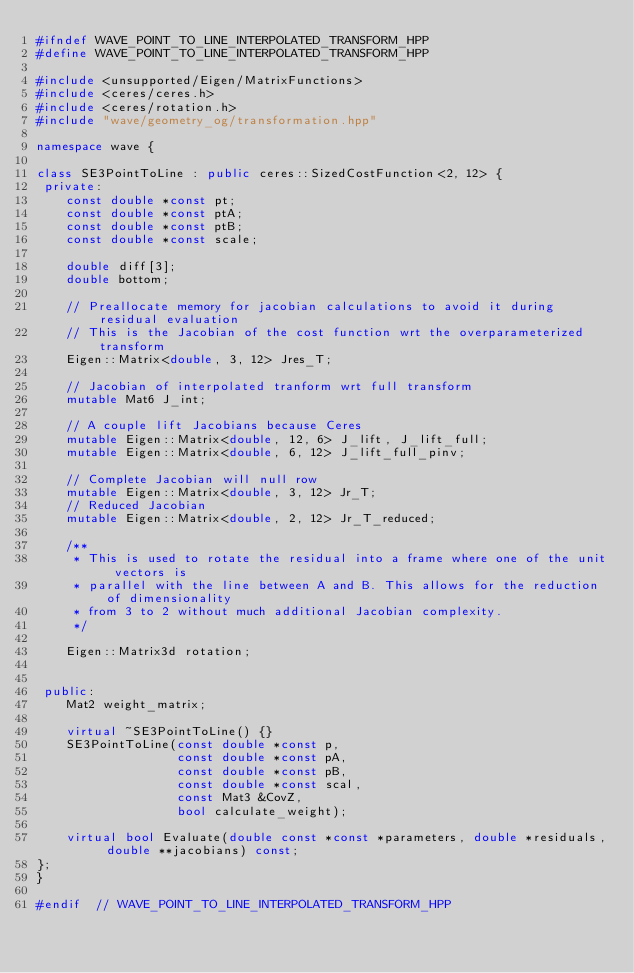<code> <loc_0><loc_0><loc_500><loc_500><_C++_>#ifndef WAVE_POINT_TO_LINE_INTERPOLATED_TRANSFORM_HPP
#define WAVE_POINT_TO_LINE_INTERPOLATED_TRANSFORM_HPP

#include <unsupported/Eigen/MatrixFunctions>
#include <ceres/ceres.h>
#include <ceres/rotation.h>
#include "wave/geometry_og/transformation.hpp"

namespace wave {

class SE3PointToLine : public ceres::SizedCostFunction<2, 12> {
 private:
    const double *const pt;
    const double *const ptA;
    const double *const ptB;
    const double *const scale;

    double diff[3];
    double bottom;

    // Preallocate memory for jacobian calculations to avoid it during residual evaluation
    // This is the Jacobian of the cost function wrt the overparameterized transform
    Eigen::Matrix<double, 3, 12> Jres_T;

    // Jacobian of interpolated tranform wrt full transform
    mutable Mat6 J_int;

    // A couple lift Jacobians because Ceres
    mutable Eigen::Matrix<double, 12, 6> J_lift, J_lift_full;
    mutable Eigen::Matrix<double, 6, 12> J_lift_full_pinv;

    // Complete Jacobian will null row
    mutable Eigen::Matrix<double, 3, 12> Jr_T;
    // Reduced Jacobian
    mutable Eigen::Matrix<double, 2, 12> Jr_T_reduced;

    /**
     * This is used to rotate the residual into a frame where one of the unit vectors is
     * parallel with the line between A and B. This allows for the reduction of dimensionality
     * from 3 to 2 without much additional Jacobian complexity.
     */

    Eigen::Matrix3d rotation;


 public:
    Mat2 weight_matrix;

    virtual ~SE3PointToLine() {}
    SE3PointToLine(const double *const p,
                   const double *const pA,
                   const double *const pB,
                   const double *const scal,
                   const Mat3 &CovZ,
                   bool calculate_weight);

    virtual bool Evaluate(double const *const *parameters, double *residuals, double **jacobians) const;
};
}

#endif  // WAVE_POINT_TO_LINE_INTERPOLATED_TRANSFORM_HPP
</code> 